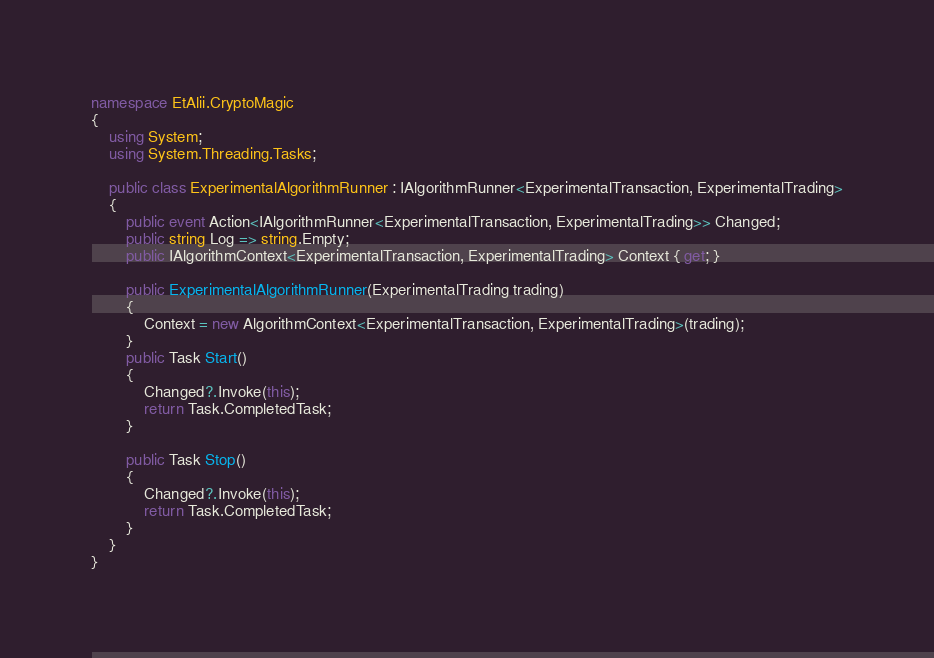Convert code to text. <code><loc_0><loc_0><loc_500><loc_500><_C#_>namespace EtAlii.CryptoMagic
{
    using System;
    using System.Threading.Tasks;

    public class ExperimentalAlgorithmRunner : IAlgorithmRunner<ExperimentalTransaction, ExperimentalTrading>
    {
        public event Action<IAlgorithmRunner<ExperimentalTransaction, ExperimentalTrading>> Changed;
        public string Log => string.Empty;
        public IAlgorithmContext<ExperimentalTransaction, ExperimentalTrading> Context { get; }

        public ExperimentalAlgorithmRunner(ExperimentalTrading trading)
        {
            Context = new AlgorithmContext<ExperimentalTransaction, ExperimentalTrading>(trading);
        }
        public Task Start()
        {
            Changed?.Invoke(this);
            return Task.CompletedTask;
        }

        public Task Stop()
        {
            Changed?.Invoke(this);
            return Task.CompletedTask;
        }
    }
}</code> 